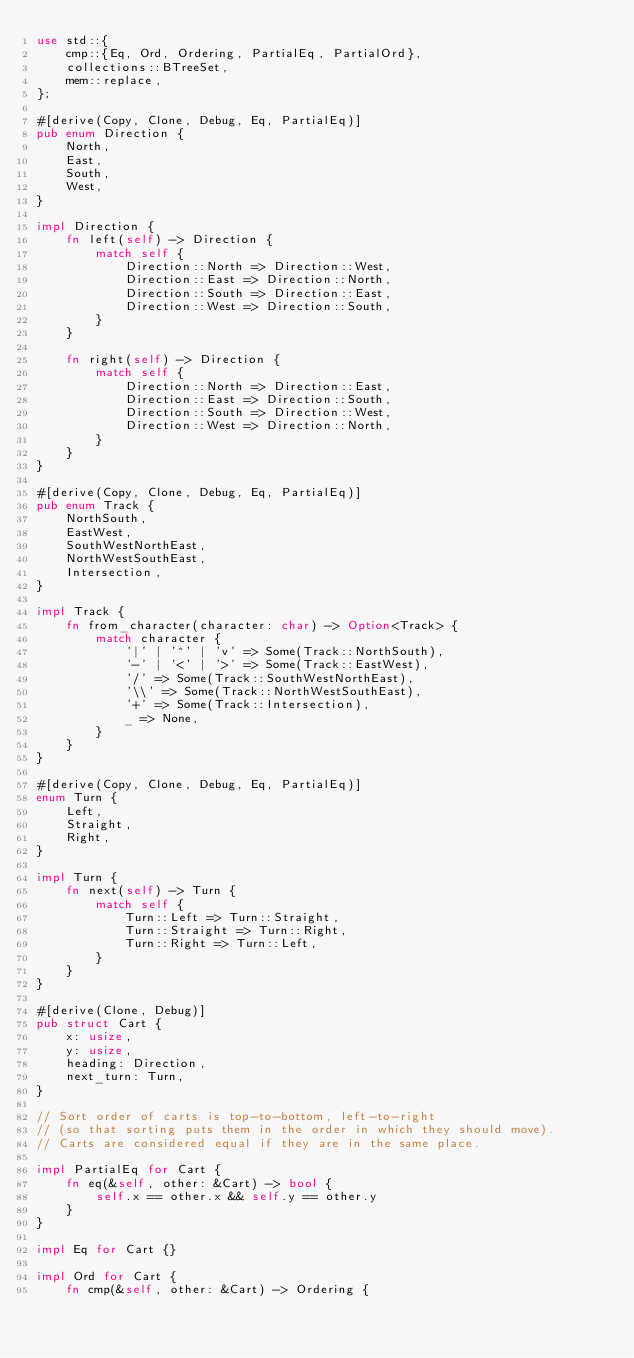Convert code to text. <code><loc_0><loc_0><loc_500><loc_500><_Rust_>use std::{
    cmp::{Eq, Ord, Ordering, PartialEq, PartialOrd},
    collections::BTreeSet,
    mem::replace,
};

#[derive(Copy, Clone, Debug, Eq, PartialEq)]
pub enum Direction {
    North,
    East,
    South,
    West,
}

impl Direction {
    fn left(self) -> Direction {
        match self {
            Direction::North => Direction::West,
            Direction::East => Direction::North,
            Direction::South => Direction::East,
            Direction::West => Direction::South,
        }
    }

    fn right(self) -> Direction {
        match self {
            Direction::North => Direction::East,
            Direction::East => Direction::South,
            Direction::South => Direction::West,
            Direction::West => Direction::North,
        }
    }
}

#[derive(Copy, Clone, Debug, Eq, PartialEq)]
pub enum Track {
    NorthSouth,
    EastWest,
    SouthWestNorthEast,
    NorthWestSouthEast,
    Intersection,
}

impl Track {
    fn from_character(character: char) -> Option<Track> {
        match character {
            '|' | '^' | 'v' => Some(Track::NorthSouth),
            '-' | '<' | '>' => Some(Track::EastWest),
            '/' => Some(Track::SouthWestNorthEast),
            '\\' => Some(Track::NorthWestSouthEast),
            '+' => Some(Track::Intersection),
            _ => None,
        }
    }
}

#[derive(Copy, Clone, Debug, Eq, PartialEq)]
enum Turn {
    Left,
    Straight,
    Right,
}

impl Turn {
    fn next(self) -> Turn {
        match self {
            Turn::Left => Turn::Straight,
            Turn::Straight => Turn::Right,
            Turn::Right => Turn::Left,
        }
    }
}

#[derive(Clone, Debug)]
pub struct Cart {
    x: usize,
    y: usize,
    heading: Direction,
    next_turn: Turn,
}

// Sort order of carts is top-to-bottom, left-to-right
// (so that sorting puts them in the order in which they should move).
// Carts are considered equal if they are in the same place.

impl PartialEq for Cart {
    fn eq(&self, other: &Cart) -> bool {
        self.x == other.x && self.y == other.y
    }
}

impl Eq for Cart {}

impl Ord for Cart {
    fn cmp(&self, other: &Cart) -> Ordering {</code> 